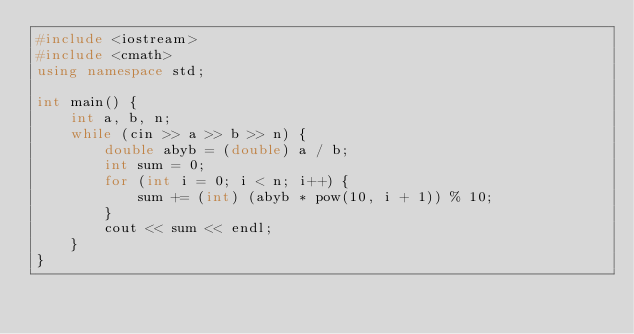Convert code to text. <code><loc_0><loc_0><loc_500><loc_500><_C++_>#include <iostream>
#include <cmath>
using namespace std;

int main() {
    int a, b, n;
    while (cin >> a >> b >> n) {
        double abyb = (double) a / b;
        int sum = 0;
        for (int i = 0; i < n; i++) {
            sum += (int) (abyb * pow(10, i + 1)) % 10;
        }
        cout << sum << endl;
    }
}</code> 